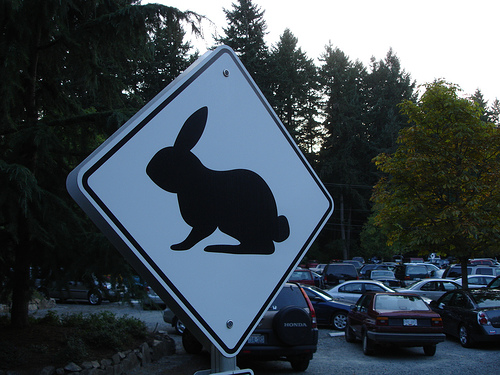<image>
Is the sign next to the car? Yes. The sign is positioned adjacent to the car, located nearby in the same general area. 